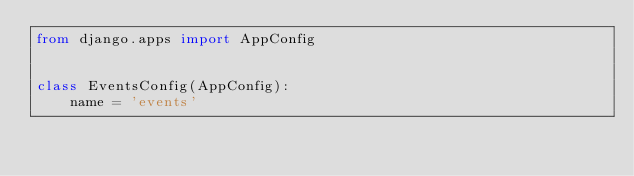<code> <loc_0><loc_0><loc_500><loc_500><_Python_>from django.apps import AppConfig


class EventsConfig(AppConfig):
    name = 'events'
</code> 